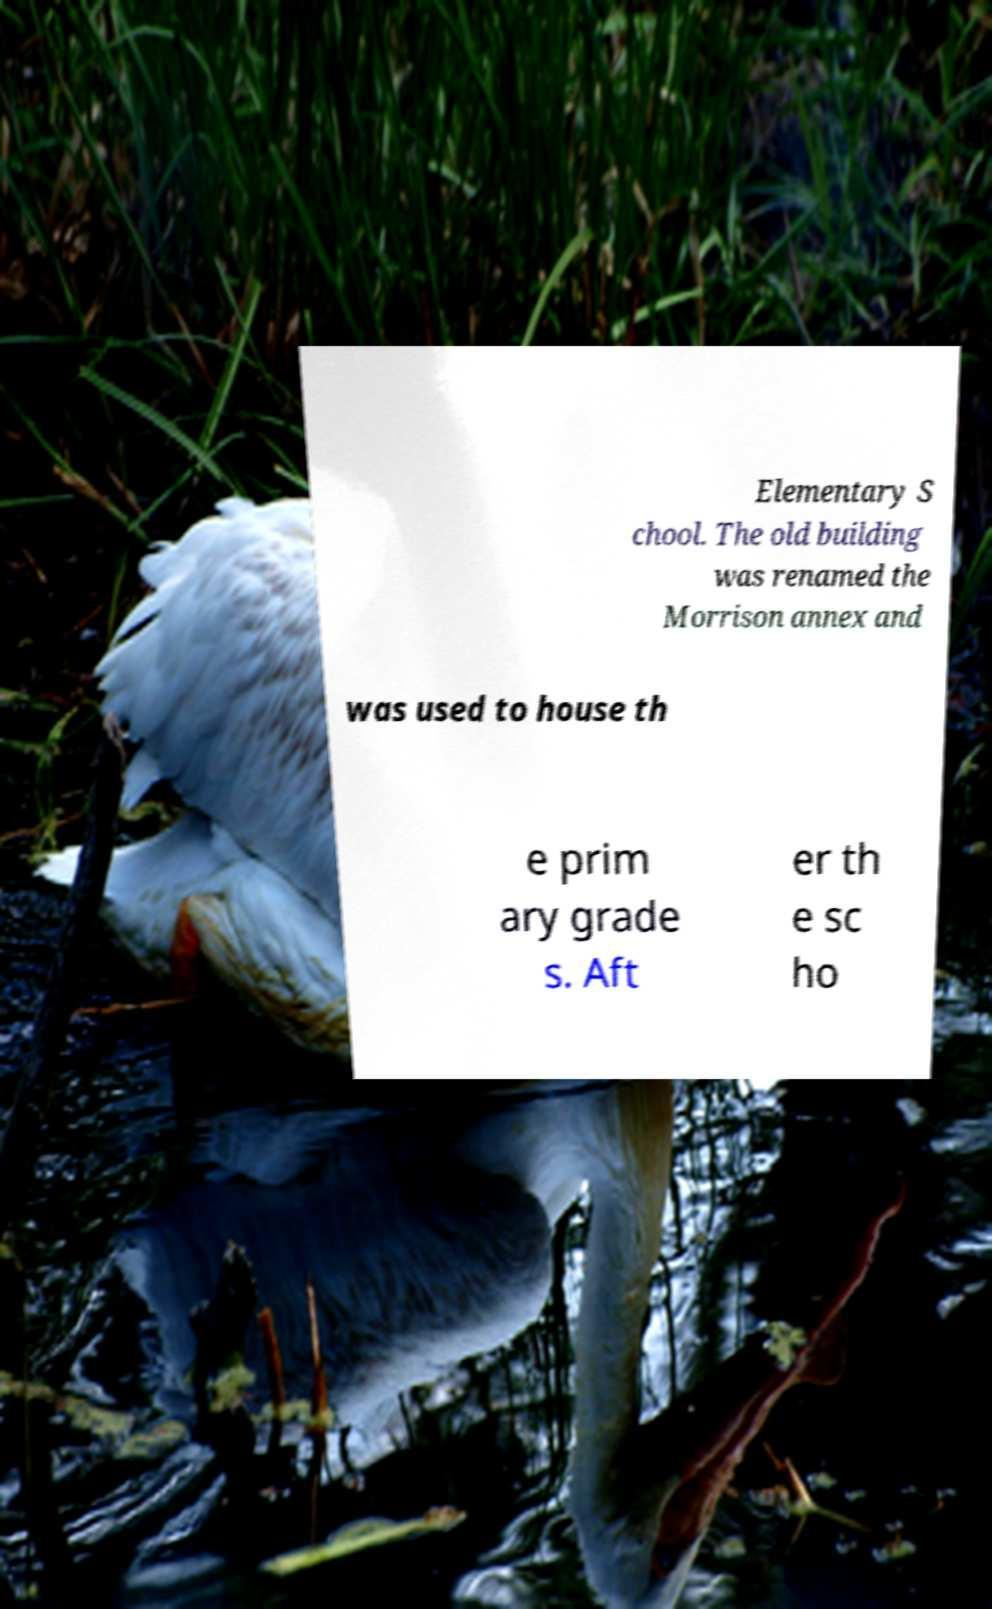There's text embedded in this image that I need extracted. Can you transcribe it verbatim? Elementary S chool. The old building was renamed the Morrison annex and was used to house th e prim ary grade s. Aft er th e sc ho 